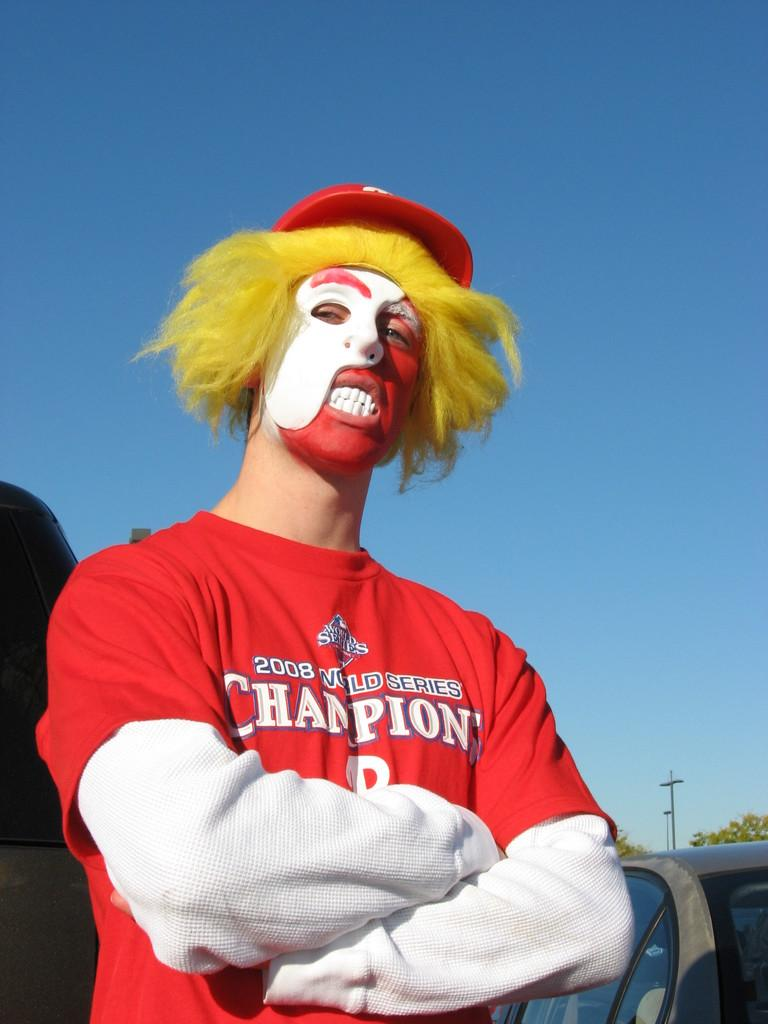Provide a one-sentence caption for the provided image. A man dressed up like a clown wears a red shirt that says "2008 World Series Champions.". 